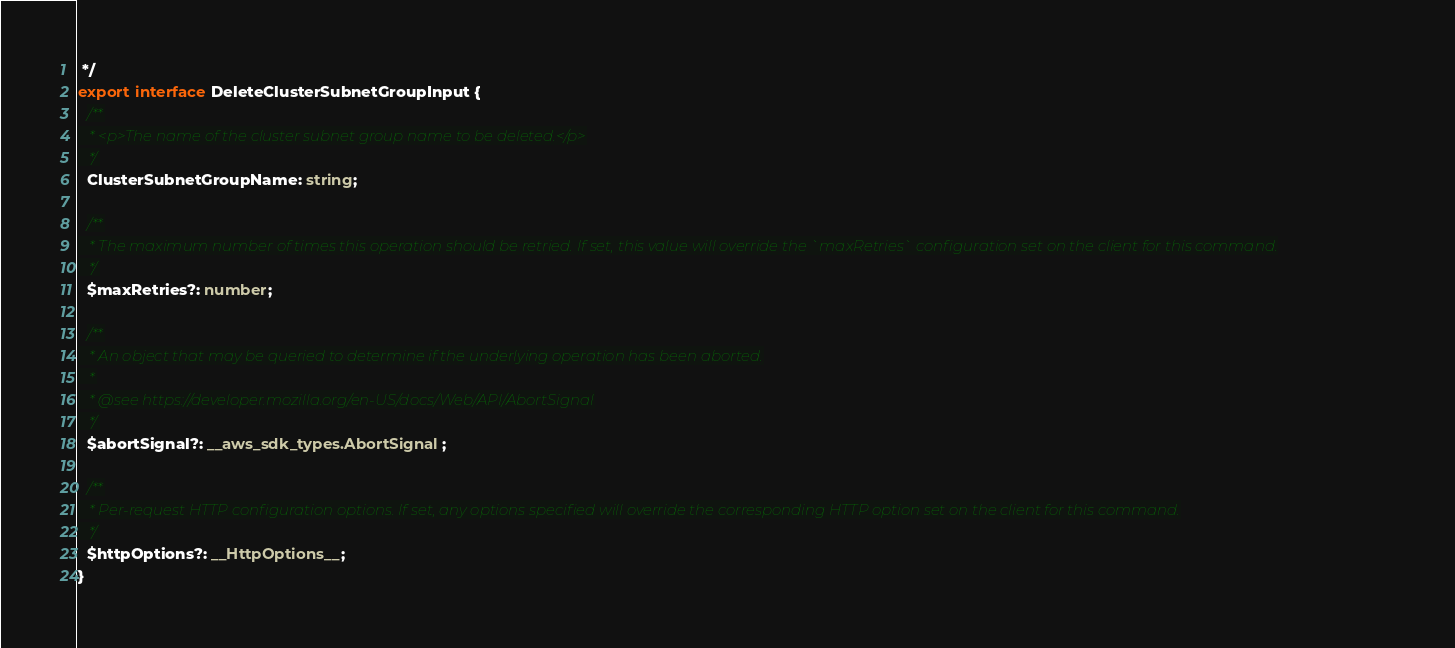<code> <loc_0><loc_0><loc_500><loc_500><_TypeScript_> */
export interface DeleteClusterSubnetGroupInput {
  /**
   * <p>The name of the cluster subnet group name to be deleted.</p>
   */
  ClusterSubnetGroupName: string;

  /**
   * The maximum number of times this operation should be retried. If set, this value will override the `maxRetries` configuration set on the client for this command.
   */
  $maxRetries?: number;

  /**
   * An object that may be queried to determine if the underlying operation has been aborted.
   *
   * @see https://developer.mozilla.org/en-US/docs/Web/API/AbortSignal
   */
  $abortSignal?: __aws_sdk_types.AbortSignal;

  /**
   * Per-request HTTP configuration options. If set, any options specified will override the corresponding HTTP option set on the client for this command.
   */
  $httpOptions?: __HttpOptions__;
}
</code> 